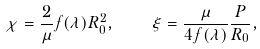<formula> <loc_0><loc_0><loc_500><loc_500>\chi = \frac { 2 } { \mu } f ( \lambda ) R _ { 0 } ^ { 2 } , \quad \xi = \frac { \mu } { 4 f ( \lambda ) } \frac { P } { R _ { 0 } } ,</formula> 